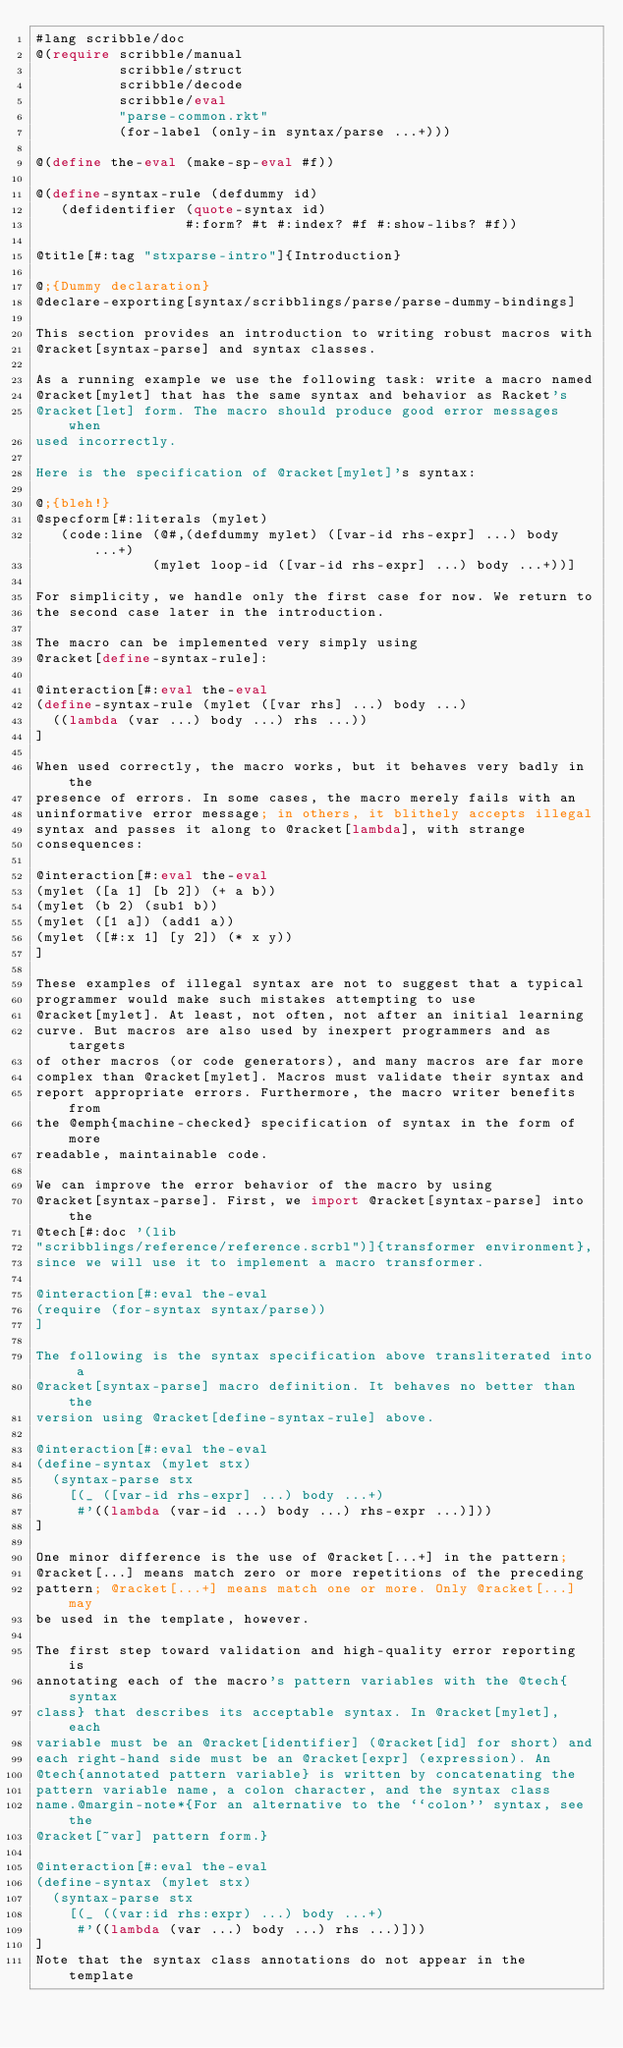Convert code to text. <code><loc_0><loc_0><loc_500><loc_500><_Racket_>#lang scribble/doc
@(require scribble/manual
          scribble/struct
          scribble/decode
          scribble/eval
          "parse-common.rkt"
          (for-label (only-in syntax/parse ...+)))

@(define the-eval (make-sp-eval #f))

@(define-syntax-rule (defdummy id)
   (defidentifier (quote-syntax id)
                  #:form? #t #:index? #f #:show-libs? #f))

@title[#:tag "stxparse-intro"]{Introduction}

@;{Dummy declaration}
@declare-exporting[syntax/scribblings/parse/parse-dummy-bindings]

This section provides an introduction to writing robust macros with
@racket[syntax-parse] and syntax classes.

As a running example we use the following task: write a macro named
@racket[mylet] that has the same syntax and behavior as Racket's
@racket[let] form. The macro should produce good error messages when
used incorrectly.

Here is the specification of @racket[mylet]'s syntax:

@;{bleh!}
@specform[#:literals (mylet)
   (code:line (@#,(defdummy mylet) ([var-id rhs-expr] ...) body ...+)
              (mylet loop-id ([var-id rhs-expr] ...) body ...+))]

For simplicity, we handle only the first case for now. We return to
the second case later in the introduction.

The macro can be implemented very simply using
@racket[define-syntax-rule]:

@interaction[#:eval the-eval
(define-syntax-rule (mylet ([var rhs] ...) body ...)
  ((lambda (var ...) body ...) rhs ...))
]

When used correctly, the macro works, but it behaves very badly in the
presence of errors. In some cases, the macro merely fails with an
uninformative error message; in others, it blithely accepts illegal
syntax and passes it along to @racket[lambda], with strange
consequences:

@interaction[#:eval the-eval
(mylet ([a 1] [b 2]) (+ a b))
(mylet (b 2) (sub1 b))
(mylet ([1 a]) (add1 a))
(mylet ([#:x 1] [y 2]) (* x y))
]

These examples of illegal syntax are not to suggest that a typical
programmer would make such mistakes attempting to use
@racket[mylet]. At least, not often, not after an initial learning
curve. But macros are also used by inexpert programmers and as targets
of other macros (or code generators), and many macros are far more
complex than @racket[mylet]. Macros must validate their syntax and
report appropriate errors. Furthermore, the macro writer benefits from
the @emph{machine-checked} specification of syntax in the form of more
readable, maintainable code.

We can improve the error behavior of the macro by using
@racket[syntax-parse]. First, we import @racket[syntax-parse] into the
@tech[#:doc '(lib
"scribblings/reference/reference.scrbl")]{transformer environment},
since we will use it to implement a macro transformer.

@interaction[#:eval the-eval
(require (for-syntax syntax/parse))
]

The following is the syntax specification above transliterated into a
@racket[syntax-parse] macro definition. It behaves no better than the
version using @racket[define-syntax-rule] above.

@interaction[#:eval the-eval
(define-syntax (mylet stx)
  (syntax-parse stx
    [(_ ([var-id rhs-expr] ...) body ...+)
     #'((lambda (var-id ...) body ...) rhs-expr ...)]))
]

One minor difference is the use of @racket[...+] in the pattern;
@racket[...] means match zero or more repetitions of the preceding
pattern; @racket[...+] means match one or more. Only @racket[...] may
be used in the template, however.

The first step toward validation and high-quality error reporting is
annotating each of the macro's pattern variables with the @tech{syntax
class} that describes its acceptable syntax. In @racket[mylet], each
variable must be an @racket[identifier] (@racket[id] for short) and
each right-hand side must be an @racket[expr] (expression). An
@tech{annotated pattern variable} is written by concatenating the
pattern variable name, a colon character, and the syntax class
name.@margin-note*{For an alternative to the ``colon'' syntax, see the
@racket[~var] pattern form.}

@interaction[#:eval the-eval
(define-syntax (mylet stx)
  (syntax-parse stx
    [(_ ((var:id rhs:expr) ...) body ...+)
     #'((lambda (var ...) body ...) rhs ...)]))
]
Note that the syntax class annotations do not appear in the template</code> 